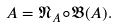Convert formula to latex. <formula><loc_0><loc_0><loc_500><loc_500>A = \mathfrak { N } _ { A } \circ { \mathfrak { B } } ( A ) .</formula> 